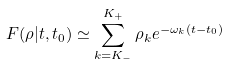<formula> <loc_0><loc_0><loc_500><loc_500>F ( \rho | t , t _ { 0 } ) \simeq \sum _ { k = K _ { - } } ^ { K _ { + } } \rho _ { k } e ^ { - \omega _ { k } ( t - t _ { 0 } ) }</formula> 